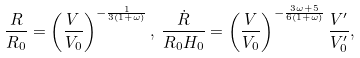<formula> <loc_0><loc_0><loc_500><loc_500>\frac { R } { R _ { 0 } } = \left ( \frac { V } { V _ { 0 } } \right ) ^ { - \frac { 1 } { 3 ( 1 + \omega ) } } , \, \frac { \dot { R } } { R _ { 0 } H _ { 0 } } = \left ( \frac { V } { V _ { 0 } } \right ) ^ { - \frac { 3 \omega + 5 } { 6 ( 1 + \omega ) } } \frac { V ^ { \prime } } { V _ { 0 } ^ { \prime } } ,</formula> 